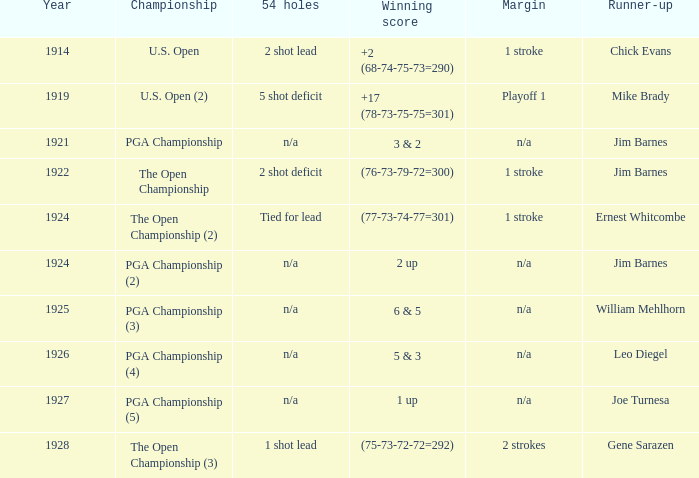WHAT YEAR DID MIKE BRADY GET RUNNER-UP? 1919.0. 